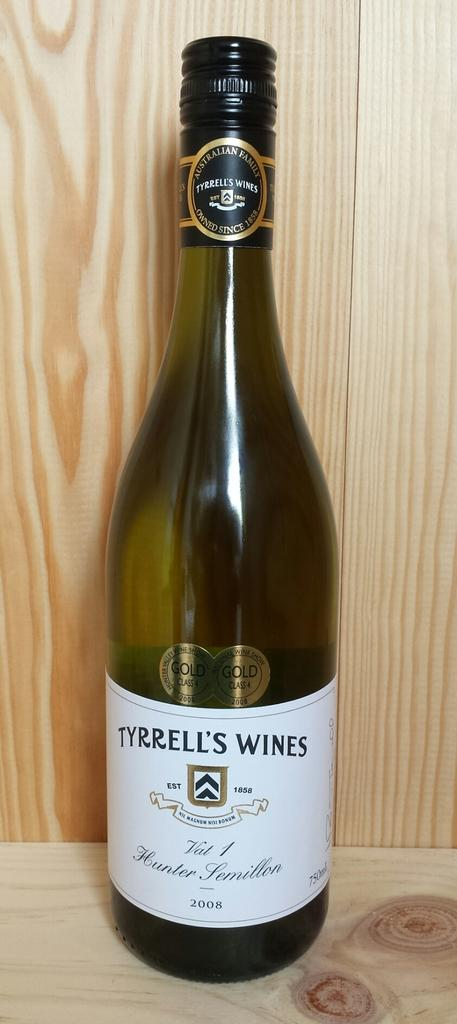<image>
Create a compact narrative representing the image presented. An unopened bottle of Tyrrell's Wines from 2008. 